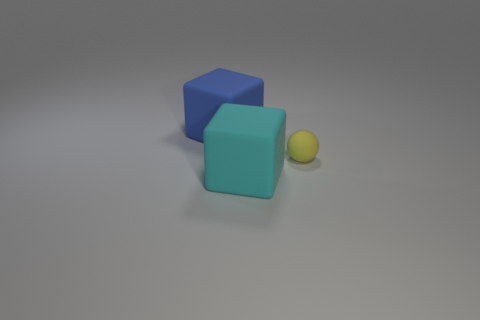Add 2 rubber objects. How many objects exist? 5 Subtract all blocks. How many objects are left? 1 Subtract 1 blue cubes. How many objects are left? 2 Subtract all tiny yellow rubber things. Subtract all large blue things. How many objects are left? 1 Add 1 large cyan matte blocks. How many large cyan matte blocks are left? 2 Add 3 matte balls. How many matte balls exist? 4 